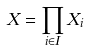Convert formula to latex. <formula><loc_0><loc_0><loc_500><loc_500>X = \prod _ { i \in I } X _ { i }</formula> 